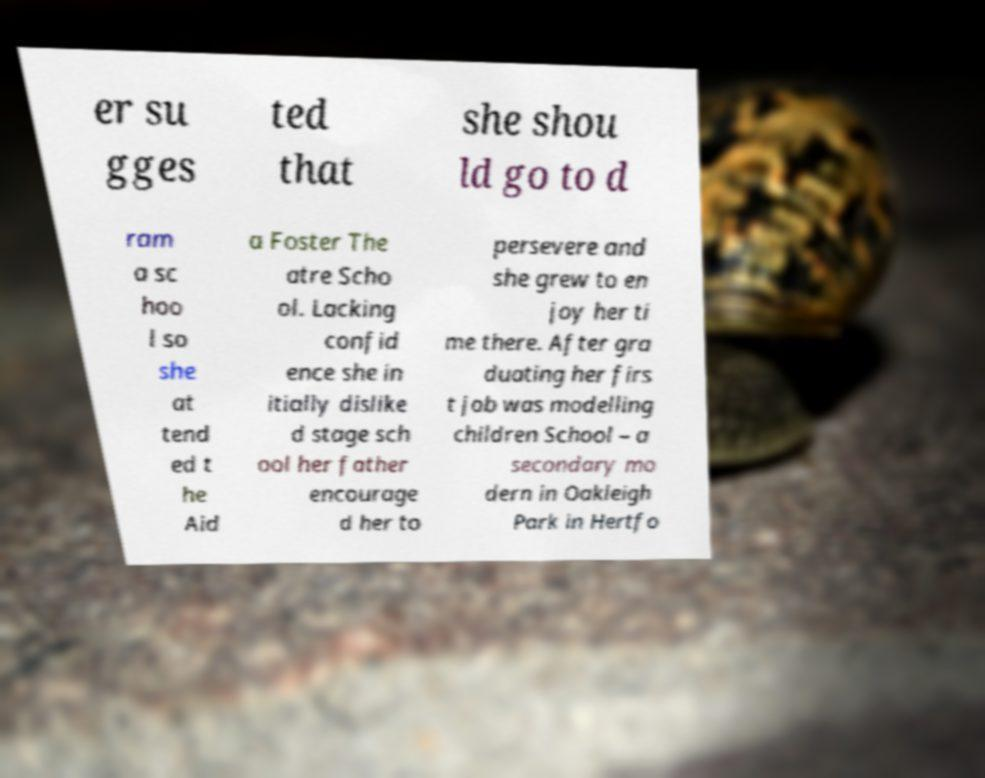Can you read and provide the text displayed in the image?This photo seems to have some interesting text. Can you extract and type it out for me? er su gges ted that she shou ld go to d ram a sc hoo l so she at tend ed t he Aid a Foster The atre Scho ol. Lacking confid ence she in itially dislike d stage sch ool her father encourage d her to persevere and she grew to en joy her ti me there. After gra duating her firs t job was modelling children School – a secondary mo dern in Oakleigh Park in Hertfo 